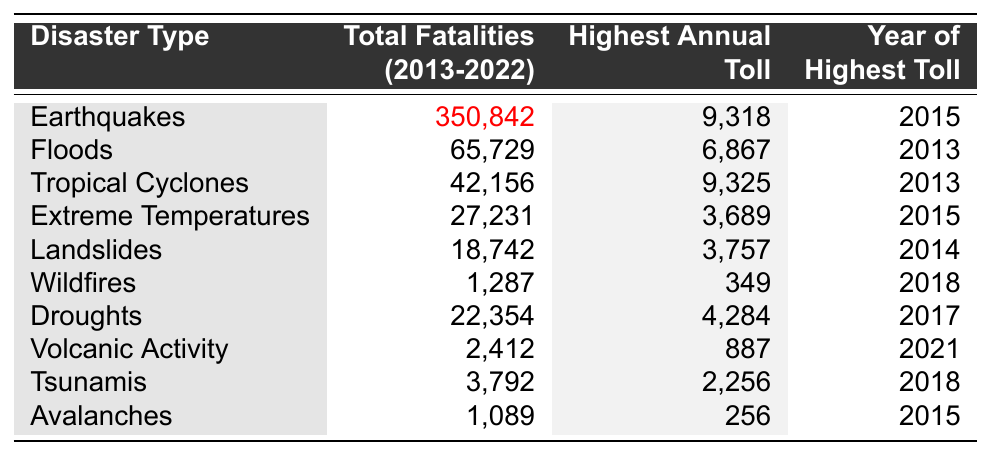What is the total number of fatalities from earthquakes between 2013 and 2022? Referring to the table, the total fatalities from earthquakes is listed as 350,842.
Answer: 350,842 Which disaster type has the highest annual toll and what was that toll? The highest annual toll listed is 9,325 for the disaster type 'Tropical Cyclones'.
Answer: Tropical Cyclones, 9,325 In which year did floods cause the highest number of fatalities? The table indicates that floods caused the highest number of fatalities in 2013, with an annual toll of 6,867.
Answer: 2013 What are the total fatalities from droughts and wildfires combined? The total fatalities for droughts is 22,354 and for wildfires is 1,287. Adding these gives 22,354 + 1,287 = 23,641.
Answer: 23,641 Did extreme temperatures cause more fatalities than landslides between 2013 and 2022? The total fatalities due to extreme temperatures is 27,231 while for landslides it's 18,742. Therefore, extreme temperatures did cause more fatalities.
Answer: Yes How many more fatalities did earthquakes have compared to floods? Earthquakes resulted in 350,842 fatalities and floods had 65,729. The difference is 350,842 - 65,729 = 285,113.
Answer: 285,113 What was the total number of fatalities for tsunamis and avalanches combined? Tsunamis caused 3,792 fatalities and avalanches caused 1,089. Adding these gives 3,792 + 1,089 = 4,881.
Answer: 4,881 Which year had the most fatalities due to extreme temperatures? The table states that the highest annual toll for extreme temperatures was 3,689 in 2015.
Answer: 2015 How many disaster types had fatalities greater than 10,000? From the table, only earthquakes and floods have fatalities greater than 10,000, totaling two disaster types.
Answer: 2 Which disaster type caused the least number of fatalities over the decade? According to the data, wildfires caused the least number of fatalities at 1,287.
Answer: Wildfires 